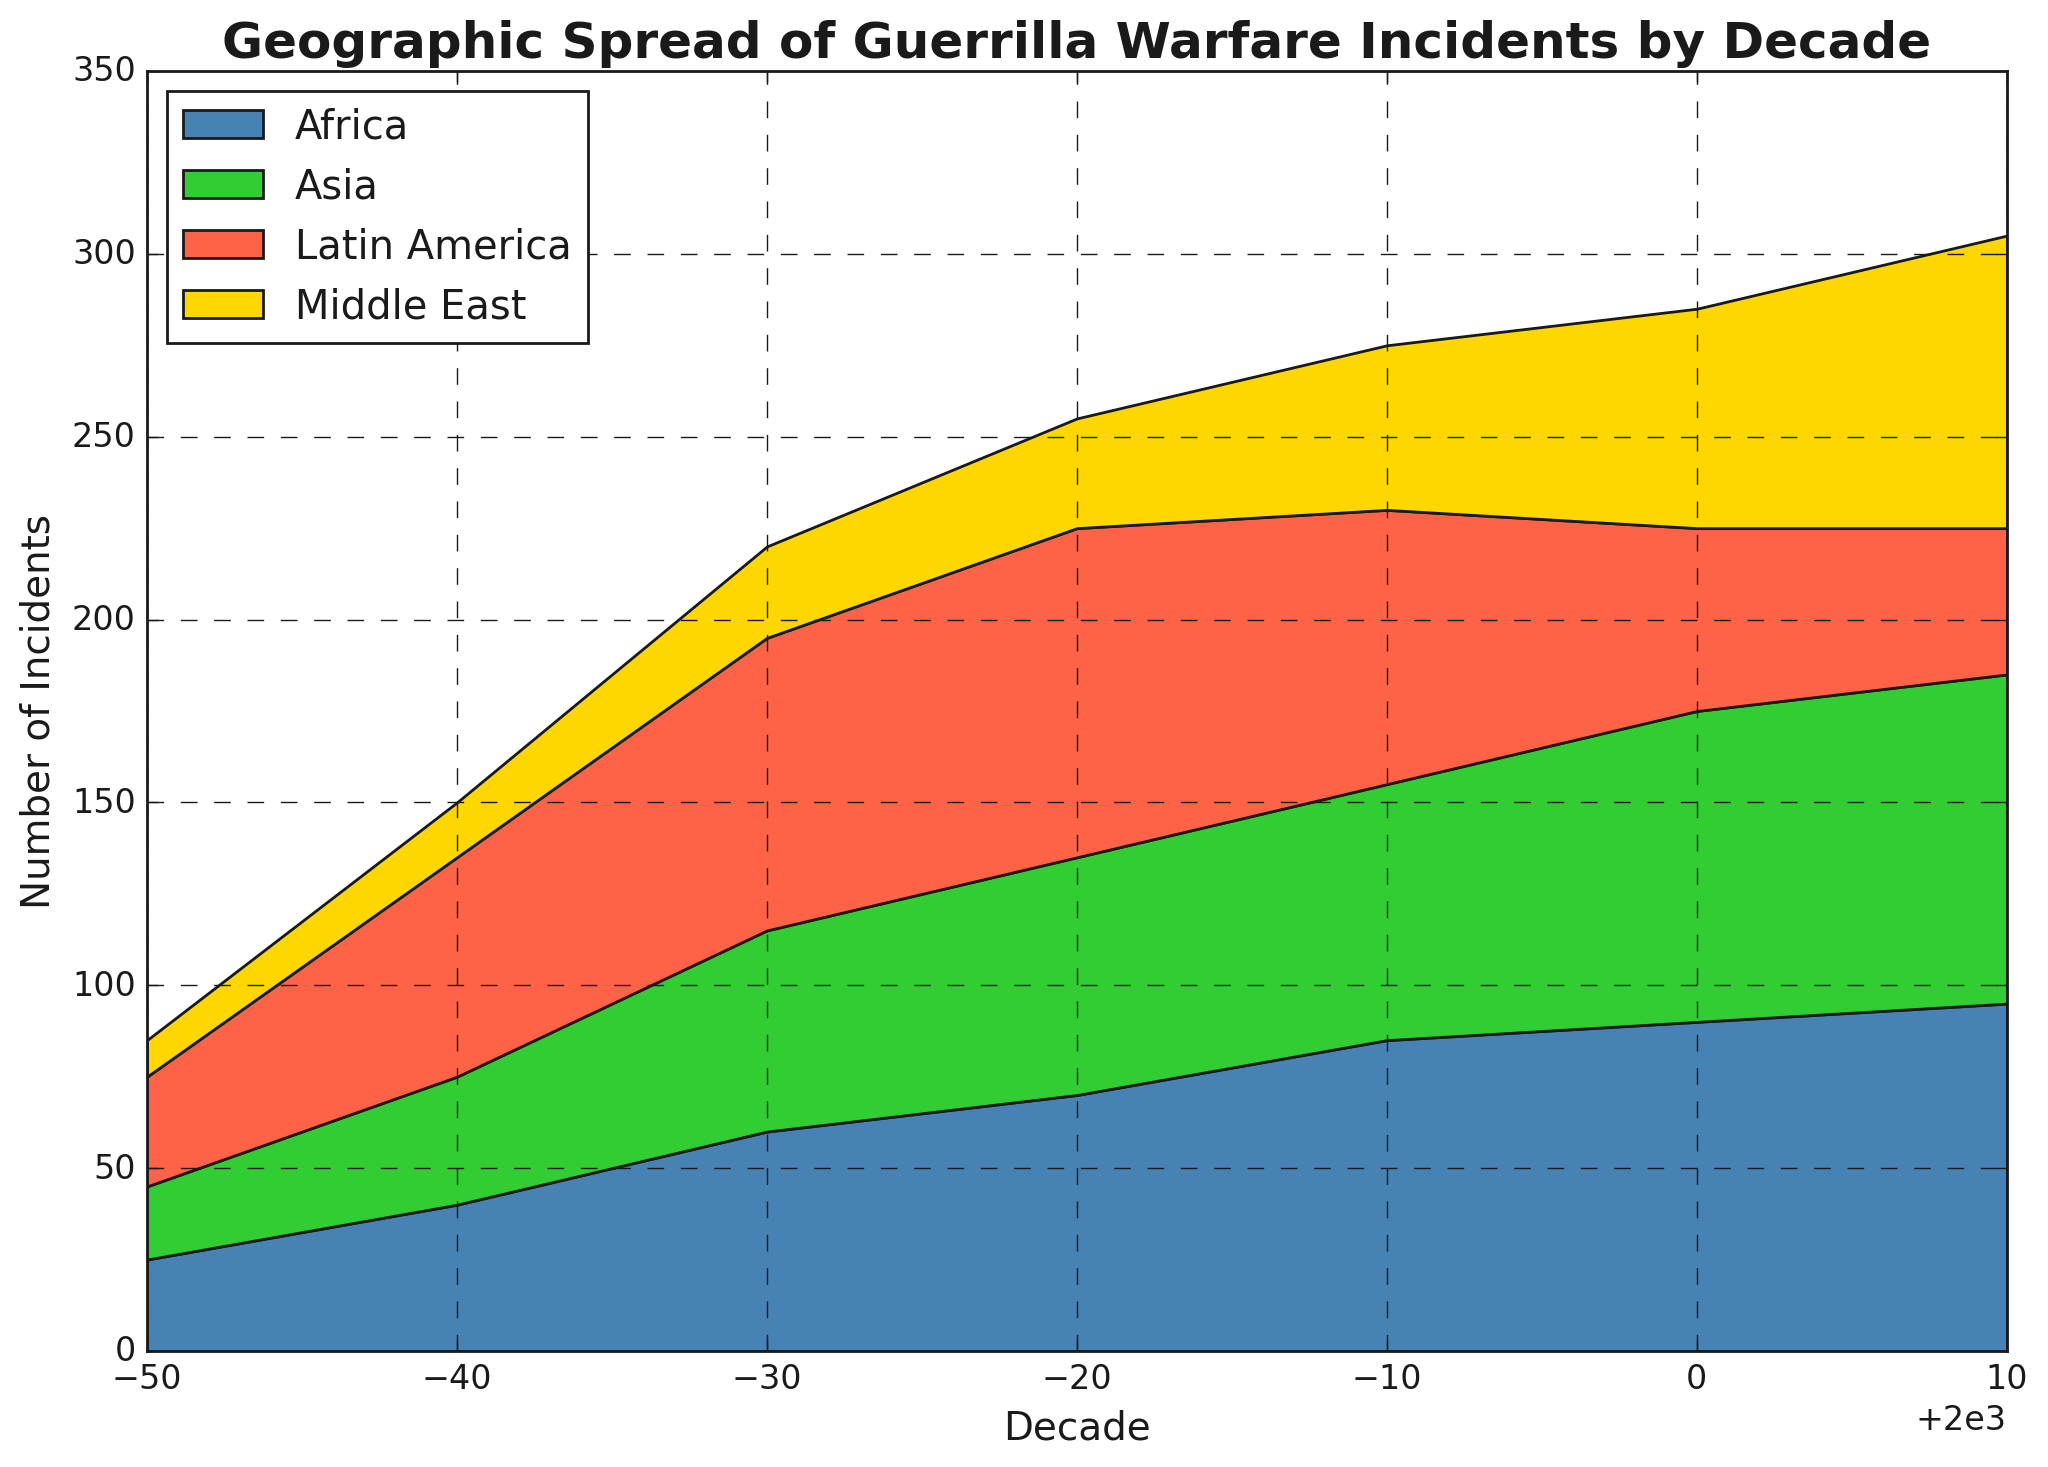What decade had the highest number of total guerrilla warfare incidents across all regions? To find the decade with the highest number of total incidents, sum the incidents for each decade. The decade with the largest sum is the answer: 1950 (30+25+20+10=85), 1960 (60+40+35+15=150), 1970 (80+60+55+25=220), 1980 (90+70+65+30=255), 1990 (75+85+70+45=275), 2000 (50+90+85+60=285), 2010 (40+95+90+80=305).
Answer: 2010 Which region had the highest number of incidents in the 2010s? To determine this, look at the values for each region in the 2010s: Latin America (40), Africa (95), Asia (90), Middle East (80). The highest number is in Africa.
Answer: Africa How did the number of incidents in the Middle East change from the 1950s to the 2010s? Compare the incidents in the Middle East in the 1950s (10) to those in the 2010s (80). The change is calculated as 80 - 10.
Answer: Increased by 70 Which region had the greatest increase in the number of incidents from the 1950s to the 2010s? Calculate the increase for each region from the 1950s to the 2010s: Latin America (40-30=10), Africa (95-25=70), Asia (90-20=70), Middle East (80-10=70). Three regions have the same largest increase.
Answer: Africa, Asia, and Middle East What was the trend for incidents in Latin America from the 1960s to the 2010s? Review the number of incidents in Latin America each decade from the 1960s (60) to 2010s (40). The trend shows: 60 (1960s), 80 (1970s), 90 (1980s), 75 (1990s), 50 (2000s), 40 (2010s). Generally decreasing after peaking in the 1980s.
Answer: Generally decreasing Compare the total number of incidents in Africa and Asia during the 2000s. Which had more incidents? Sum incidents in Africa (90) and Asia (85). Compare the sums to see which is higher.
Answer: Africa What visual color corresponds to the region with the lowest number of incidents in the 1970s? According to the data in the 1970s: Latin America (80), Africa (60), Asia (55), Middle East (25). The lowest number (25) corresponds to the Middle East, which is colored yellow.
Answer: Yellow What was the difference in the number of incidents between Latin America and Middle East in the 1980s? Look at the data for the 1980s: Latin America (90), Middle East (30). Subtract the number in Middle East from Latin America: 90 - 30.
Answer: 60 How does the height of the area for Africa change from 1950 to 2010? Assess the height of the area in the plot for Africa across decades: 25 (1950s), 40 (1960s), 60 (1970s), 70 (1980s), 85 (1990s), 90 (2000s), 95 (2010s). The height consistently increases each decade.
Answer: Increases consistently Which decade had the lowest total number of incidents? Sum the incidents for each decade and find the lowest sum: 1950 (85), 1960 (150), 1970 (220), 1980 (255), 1990 (275), 2000 (285), 2010 (305). The lowest sum is in the 1950s.
Answer: 1950s 